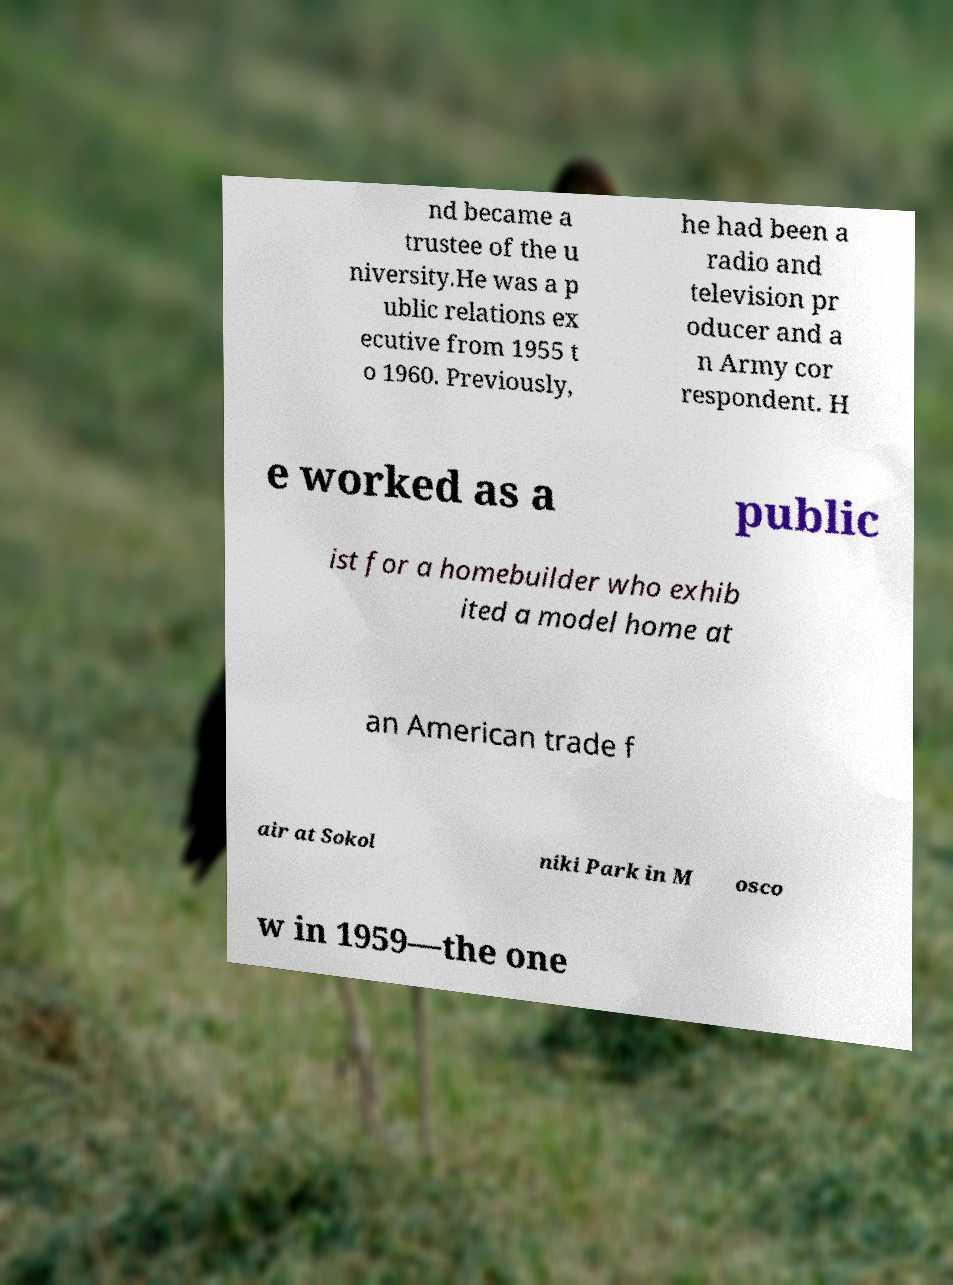There's text embedded in this image that I need extracted. Can you transcribe it verbatim? nd became a trustee of the u niversity.He was a p ublic relations ex ecutive from 1955 t o 1960. Previously, he had been a radio and television pr oducer and a n Army cor respondent. H e worked as a public ist for a homebuilder who exhib ited a model home at an American trade f air at Sokol niki Park in M osco w in 1959—the one 